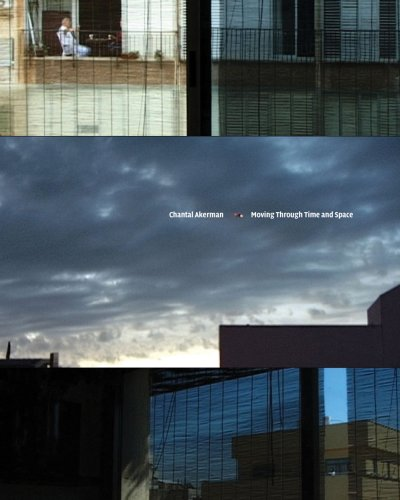What might be the significance of the cloud imagery on the book cover? The clouds may symbolize a sense of transience and the fleeting nature of time, themes that are prevalent in Chantal Akerman's work, emphasizing the ephemeral quality of human experiences. 